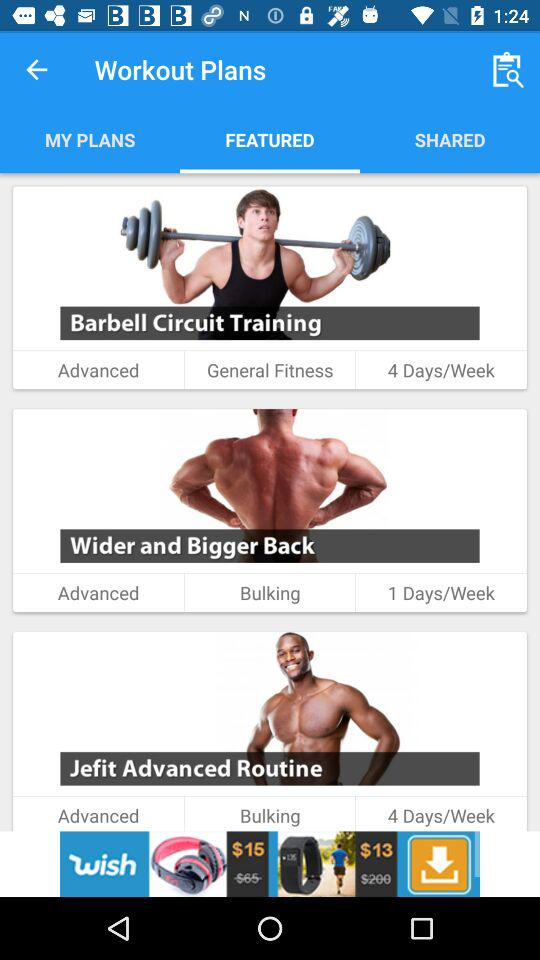Which is the selected tab? The selected tab is "FEATURED". 